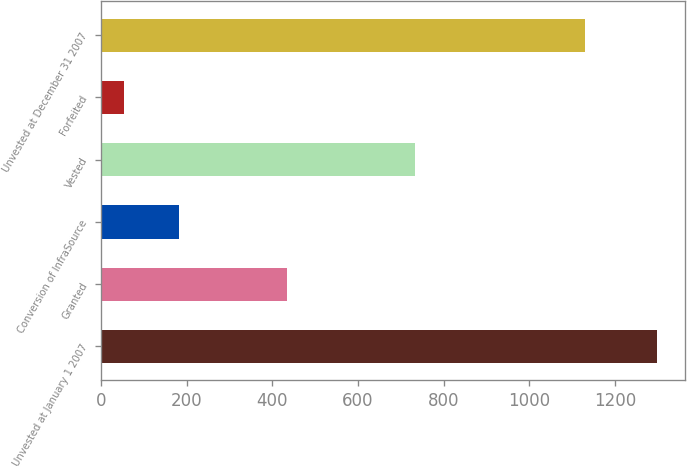Convert chart. <chart><loc_0><loc_0><loc_500><loc_500><bar_chart><fcel>Unvested at January 1 2007<fcel>Granted<fcel>Conversion of InfraSource<fcel>Vested<fcel>Forfeited<fcel>Unvested at December 31 2007<nl><fcel>1298<fcel>434<fcel>183<fcel>732<fcel>54<fcel>1129<nl></chart> 